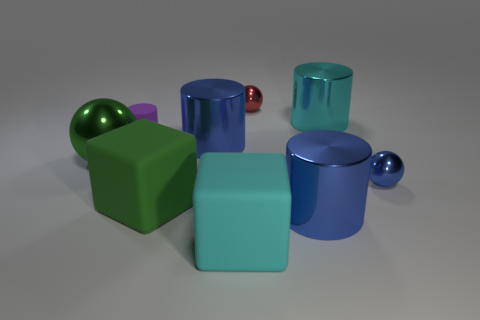Add 1 purple things. How many objects exist? 10 Subtract all cylinders. How many objects are left? 5 Add 2 large gray rubber cylinders. How many large gray rubber cylinders exist? 2 Subtract 0 green cylinders. How many objects are left? 9 Subtract all blue metallic cylinders. Subtract all big green rubber blocks. How many objects are left? 6 Add 2 large green metallic things. How many large green metallic things are left? 3 